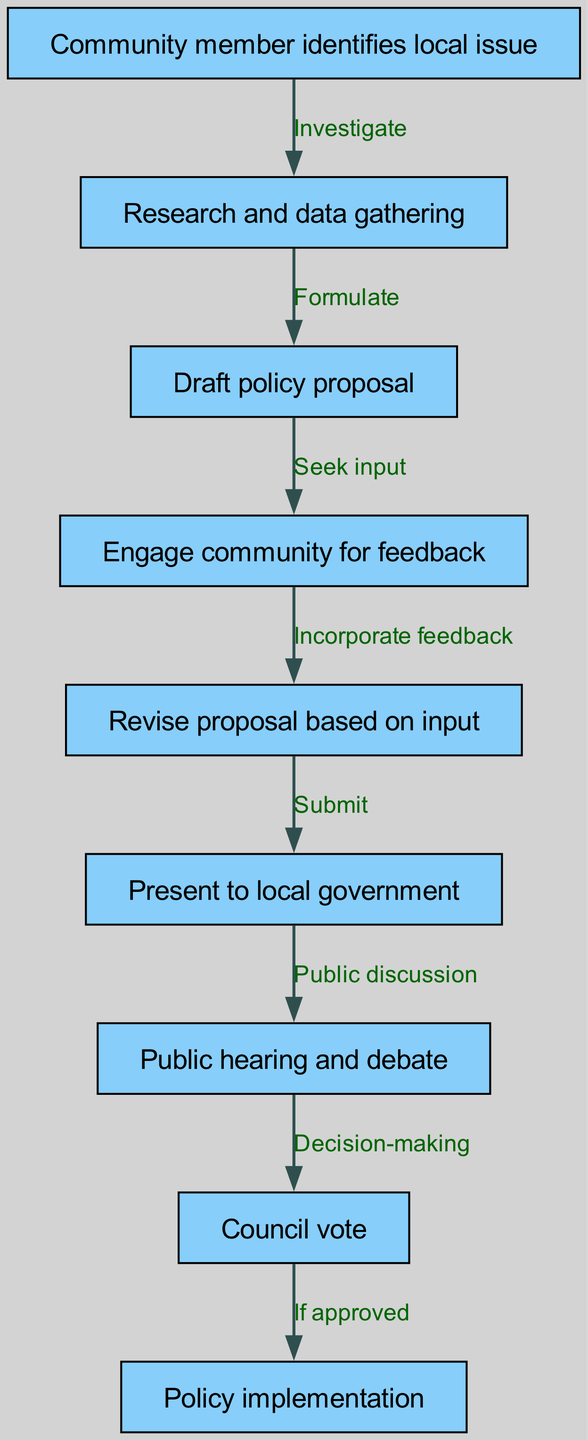What is the first step in the policy proposal journey? The first step is indicated by the node "Community member identifies local issue," which is the starting point of the flow chart.
Answer: Community member identifies local issue How many total nodes are in the diagram? By counting the distinct entries under "nodes," there are a total of nine nodes described in the diagram.
Answer: 9 What action follows "Draft policy proposal"? "Seek input" follows "Draft policy proposal," as it's the next node connected to it in the flow.
Answer: Seek input What is the final outcome of the policy proposal journey if approved? The final outcome is shown as "Policy implementation," which is the last node that concludes the outlined process.
Answer: Policy implementation What connects the “Engage community for feedback” to the next step? The connection is labeled as "Incorporate feedback," indicating that feedback is added or considered in preparing the next action.
Answer: Incorporate feedback Which nodes represent decision-making points in the journey? The nodes "Public hearing and debate" and "Council vote" represent the decision-making points where community input and governmental action occur.
Answer: Public hearing and debate, Council vote How does a proposal transition from the community engagement stage to the local government presentation? The transition from "Revise proposal based on input" to "Present to local government" happens after the proposal is finalized based on community feedback.
Answer: Submit What is the nature of the edge between "Council vote" and "Policy implementation"? The edge indicates a conditional flow with the label "If approved," suggesting that implementation only occurs upon receiving approval from the council.
Answer: If approved 